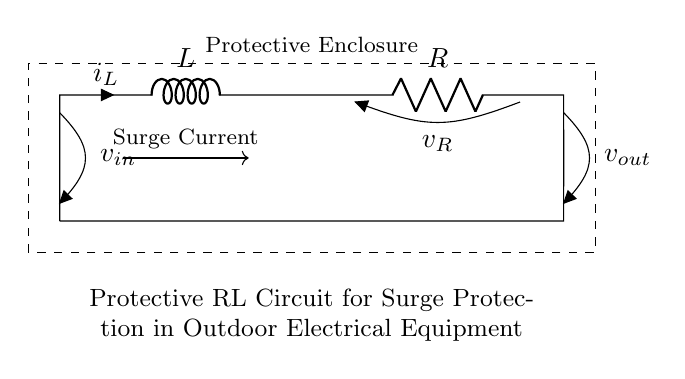What are the components in the circuit? The components in the circuit are a resistor and an inductor, as indicated by the symbols R and L in the diagram.
Answer: Resistor and Inductor What is the function of the inductor in this circuit? The inductor's function is to resist changes in current flow, which helps to absorb surge currents in the protective circuit.
Answer: Absorbing surge currents What is the voltage across the resistor labeled as? The voltage across the resistor is labeled as v_R in the circuit diagram.
Answer: v_R How does the current flow in this RL circuit? The current flows from the input voltage source, through the inductor and resistor, and returns back to the source, creating a closed loop.
Answer: Closed loop What happens to surge current when it enters this circuit? The surge current is managed by the inductor, which helps to reduce its abrupt changes and protect outdoor equipment from voltage spikes.
Answer: Reduces abrupt changes What is the purpose of the protective enclosure shown in the diagram? The protective enclosure serves to shield the circuit components from external environmental factors, ensuring their durability and reliability during outdoor use.
Answer: Shield circuit components What type of protection does this RL circuit offer? This RL circuit provides surge protection, which safeguards equipment from spikes in electrical current potentially caused by external factors like lightning or power surges.
Answer: Surge protection 